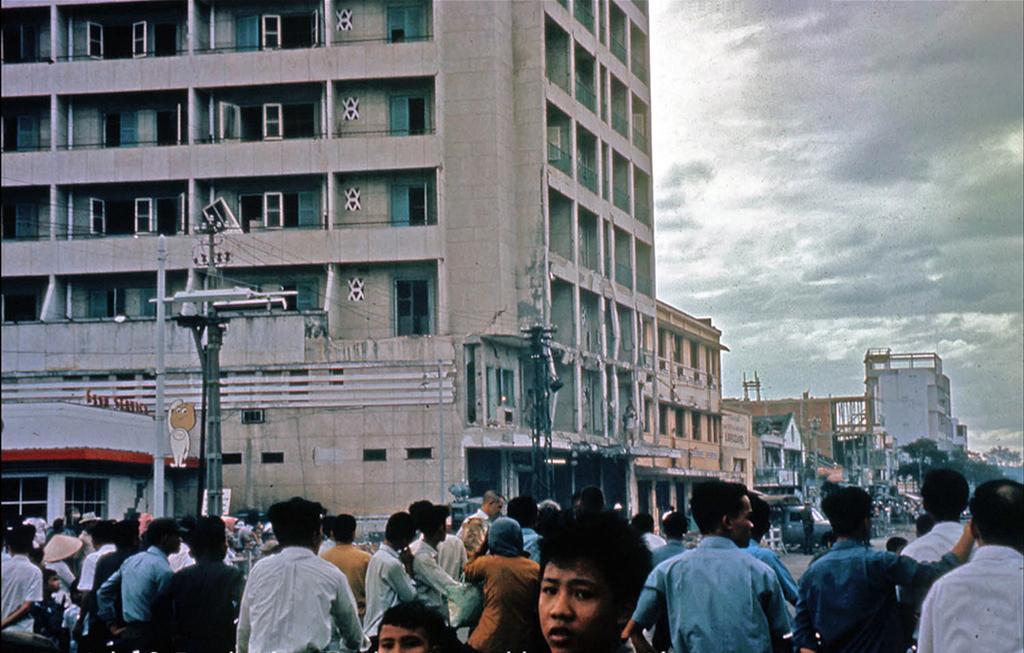In one or two sentences, can you explain what this image depicts? In this picture we can see a group of people and a vehicle on the ground, poles, trees, buildings with windows and in the background we can see the sky with clouds. 